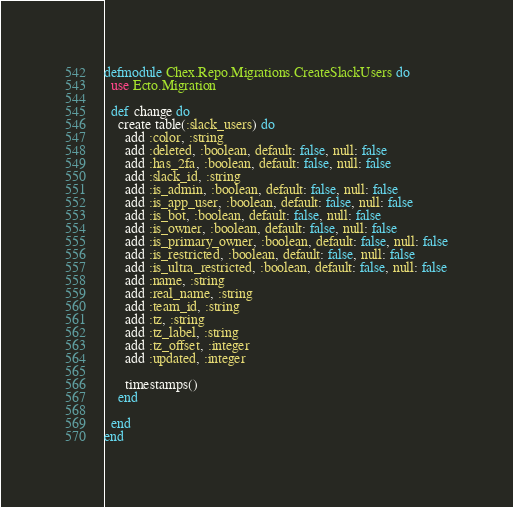Convert code to text. <code><loc_0><loc_0><loc_500><loc_500><_Elixir_>defmodule Chex.Repo.Migrations.CreateSlackUsers do
  use Ecto.Migration

  def change do
    create table(:slack_users) do
      add :color, :string
      add :deleted, :boolean, default: false, null: false
      add :has_2fa, :boolean, default: false, null: false
      add :slack_id, :string
      add :is_admin, :boolean, default: false, null: false
      add :is_app_user, :boolean, default: false, null: false
      add :is_bot, :boolean, default: false, null: false
      add :is_owner, :boolean, default: false, null: false
      add :is_primary_owner, :boolean, default: false, null: false
      add :is_restricted, :boolean, default: false, null: false
      add :is_ultra_restricted, :boolean, default: false, null: false
      add :name, :string
      add :real_name, :string
      add :team_id, :string
      add :tz, :string
      add :tz_label, :string
      add :tz_offset, :integer
      add :updated, :integer

      timestamps()
    end

  end
end
</code> 